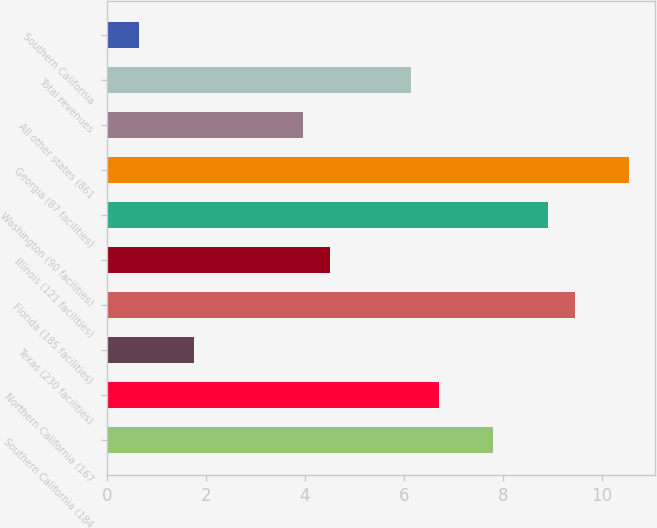<chart> <loc_0><loc_0><loc_500><loc_500><bar_chart><fcel>Southern California (184<fcel>Northern California (167<fcel>Texas (230 facilities)<fcel>Florida (185 facilities)<fcel>Illinois (121 facilities)<fcel>Washington (90 facilities)<fcel>Georgia (87 facilities)<fcel>All other states (861<fcel>Total revenues<fcel>Southern California<nl><fcel>7.8<fcel>6.7<fcel>1.75<fcel>9.45<fcel>4.5<fcel>8.9<fcel>10.55<fcel>3.95<fcel>6.15<fcel>0.65<nl></chart> 